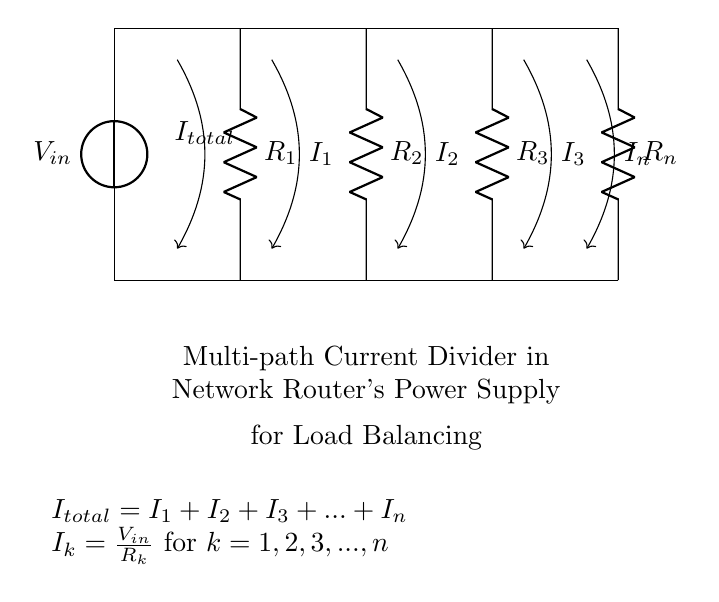What is the supply voltage in this circuit? The supply voltage is represented by the voltage source symbol labeled V_in at the top of the circuit diagram.
Answer: V_in What happens to the total current as more resistors are added in parallel? Adding more resistors in parallel decreases the total equivalent resistance, leading to an increase in total current according to Ohm's Law (V = IR).
Answer: Total current increases What type of current divider is depicted in this circuit? The circuit represents a multi-path current divider because it has multiple resistors connected in parallel, allowing current to divide among different paths.
Answer: Multi-path current divider How is the current through resistor R_k calculated? The current through each resistor, denoted as I_k, is calculated using the formula I_k = V_in / R_k, where R_k is the resistance of the k-th resistor in the circuit.
Answer: I_k = V_in / R_k What can be concluded about the sum of the individual branch currents? The sum of the individual branch currents (I_1, I_2, I_3, ..., I_n) equals the total incoming current (I_total), according to the current conservation principle at a junction.
Answer: I_total = I_1 + I_2 + I_3 + ... + I_n 